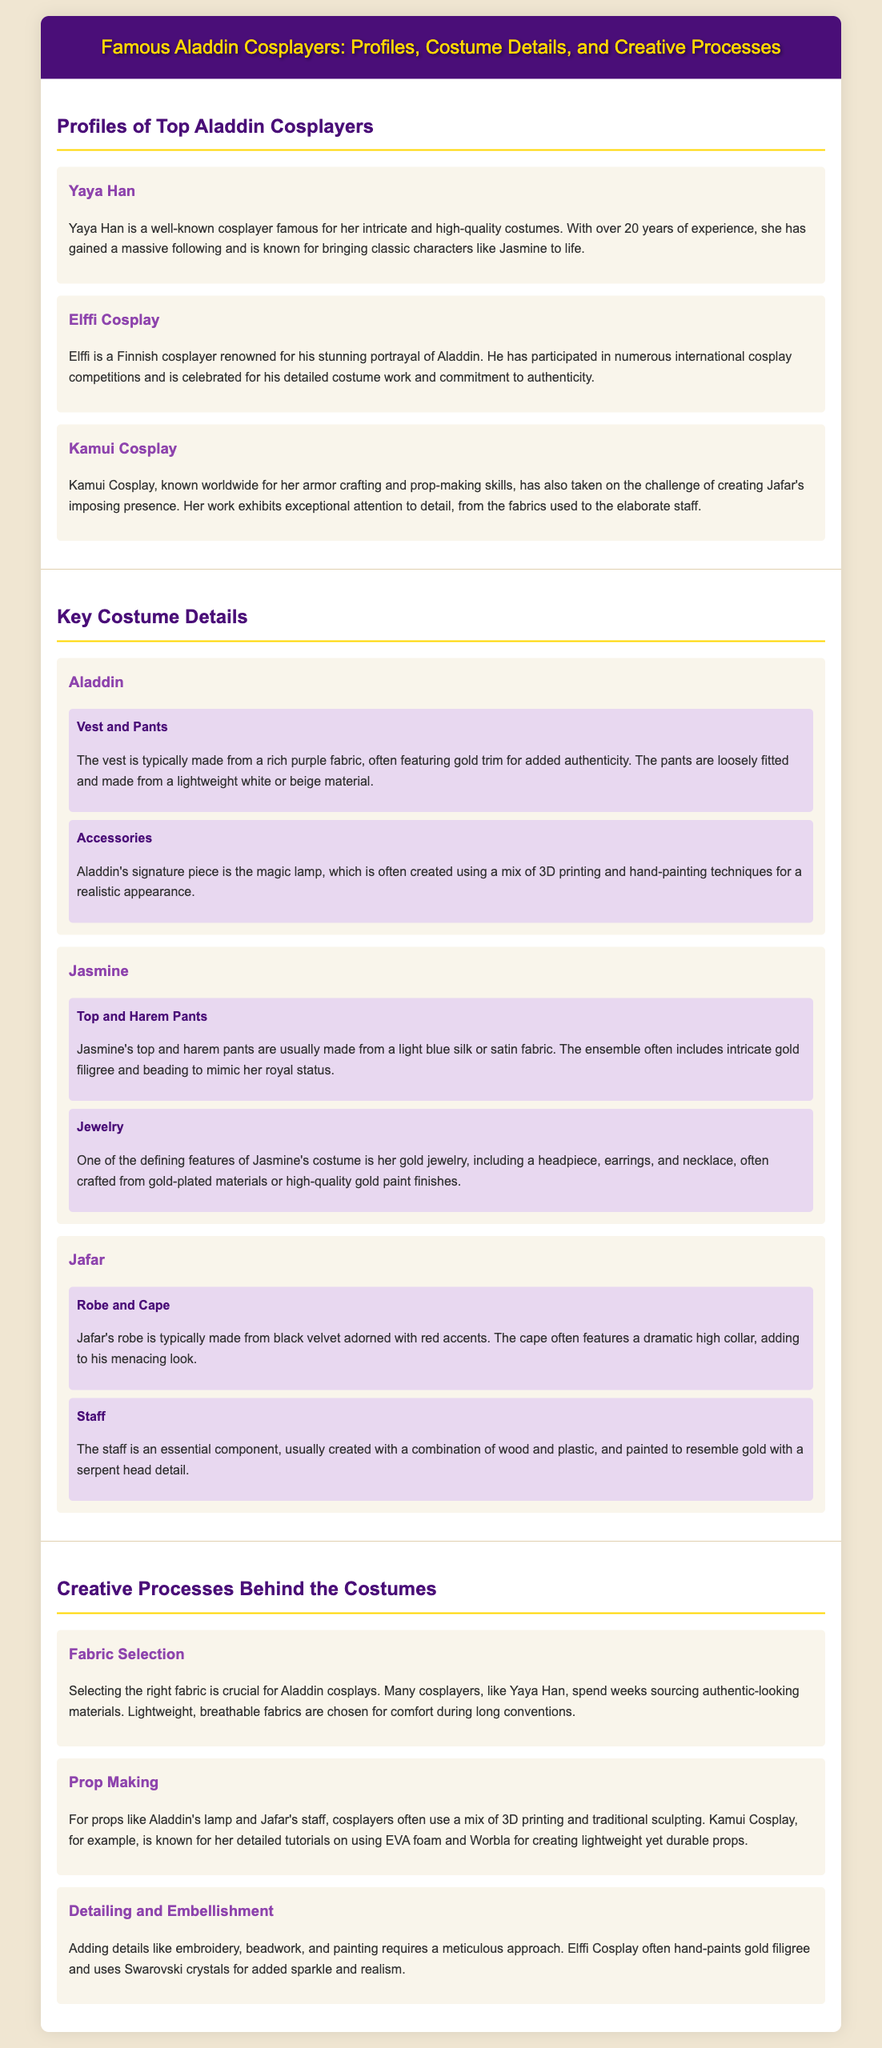What is Yaya Han known for? Yaya Han is known for her intricate and high-quality costumes.
Answer: intricate and high-quality costumes Who is Elffi? Elffi is a Finnish cosplayer renowned for his stunning portrayal of Aladdin.
Answer: Finnish cosplayer What color is Aladdin's vest typically made from? The vest is typically made from a rich purple fabric.
Answer: rich purple Which cosplayer is known for her armor crafting and prop-making skills? Kamui Cosplay is known for her armor crafting and prop-making skills.
Answer: Kamui Cosplay What material is Jafar's robe made from? Jafar's robe is typically made from black velvet.
Answer: black velvet How long has Yaya Han been cosplaying? Yaya Han has over 20 years of experience.
Answer: over 20 years What jewelry is a defining feature of Jasmine's costume? Jasmine's costume features gold jewelry.
Answer: gold jewelry Which cosplayer uses Swarovski crystals for detailing? Elffi Cosplay uses Swarovski crystals for detailing.
Answer: Elffi Cosplay What is key to the creative process of selecting fabric? Selecting the right fabric is crucial for Aladdin cosplays.
Answer: crucial for Aladdin cosplays 